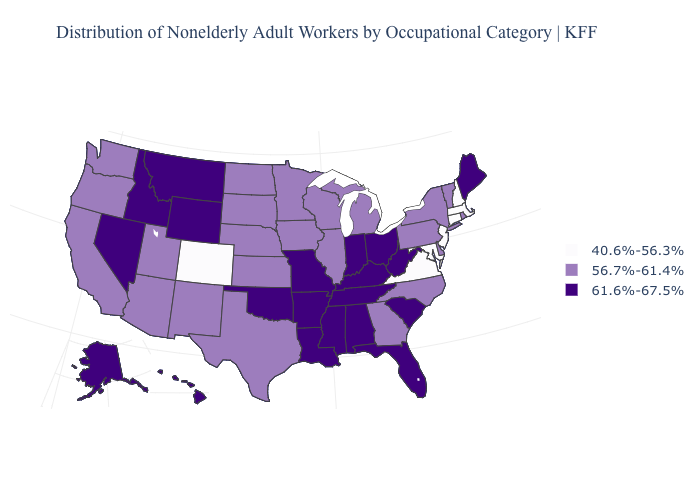What is the highest value in the USA?
Short answer required. 61.6%-67.5%. Among the states that border West Virginia , which have the lowest value?
Concise answer only. Maryland, Virginia. What is the value of Montana?
Keep it brief. 61.6%-67.5%. Does Maine have the highest value in the Northeast?
Concise answer only. Yes. Does Pennsylvania have the highest value in the USA?
Quick response, please. No. Among the states that border New York , which have the highest value?
Answer briefly. Pennsylvania, Vermont. How many symbols are there in the legend?
Quick response, please. 3. Does Maryland have the lowest value in the USA?
Short answer required. Yes. Which states have the lowest value in the Northeast?
Concise answer only. Connecticut, Massachusetts, New Hampshire, New Jersey. Does the map have missing data?
Answer briefly. No. Which states hav the highest value in the South?
Write a very short answer. Alabama, Arkansas, Florida, Kentucky, Louisiana, Mississippi, Oklahoma, South Carolina, Tennessee, West Virginia. Among the states that border Ohio , does West Virginia have the highest value?
Keep it brief. Yes. Name the states that have a value in the range 40.6%-56.3%?
Write a very short answer. Colorado, Connecticut, Maryland, Massachusetts, New Hampshire, New Jersey, Virginia. Name the states that have a value in the range 56.7%-61.4%?
Be succinct. Arizona, California, Delaware, Georgia, Illinois, Iowa, Kansas, Michigan, Minnesota, Nebraska, New Mexico, New York, North Carolina, North Dakota, Oregon, Pennsylvania, Rhode Island, South Dakota, Texas, Utah, Vermont, Washington, Wisconsin. What is the value of Texas?
Answer briefly. 56.7%-61.4%. 